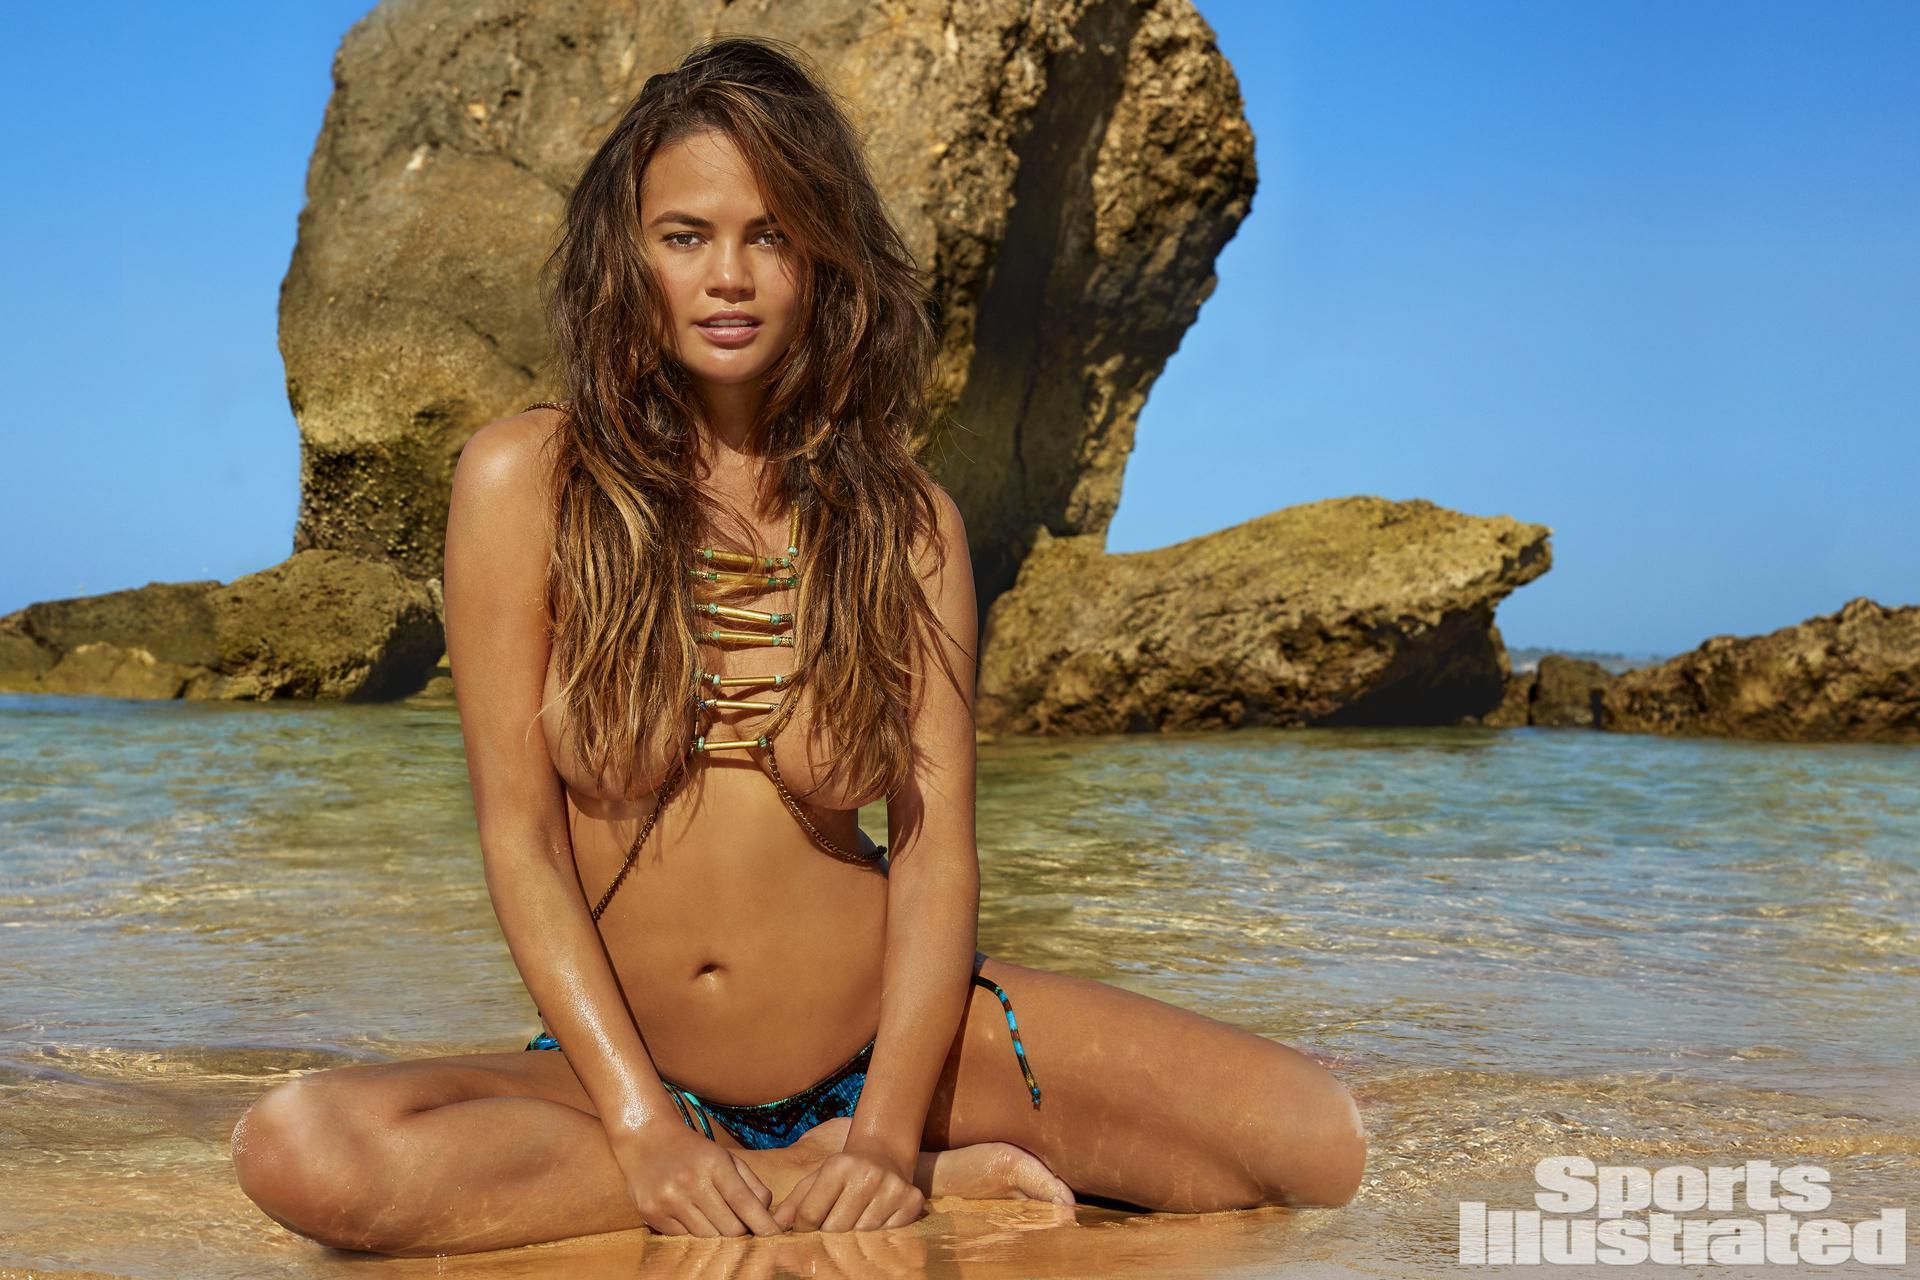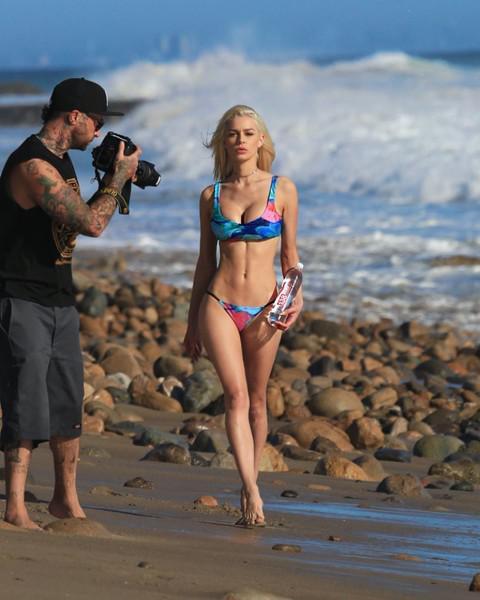The first image is the image on the left, the second image is the image on the right. Considering the images on both sides, is "The right image shows one blonde model in a printed bikini with the arm on the left raised to her head and boulders behind her." valid? Answer yes or no. No. The first image is the image on the left, the second image is the image on the right. Given the left and right images, does the statement "There are exactly two women." hold true? Answer yes or no. Yes. 